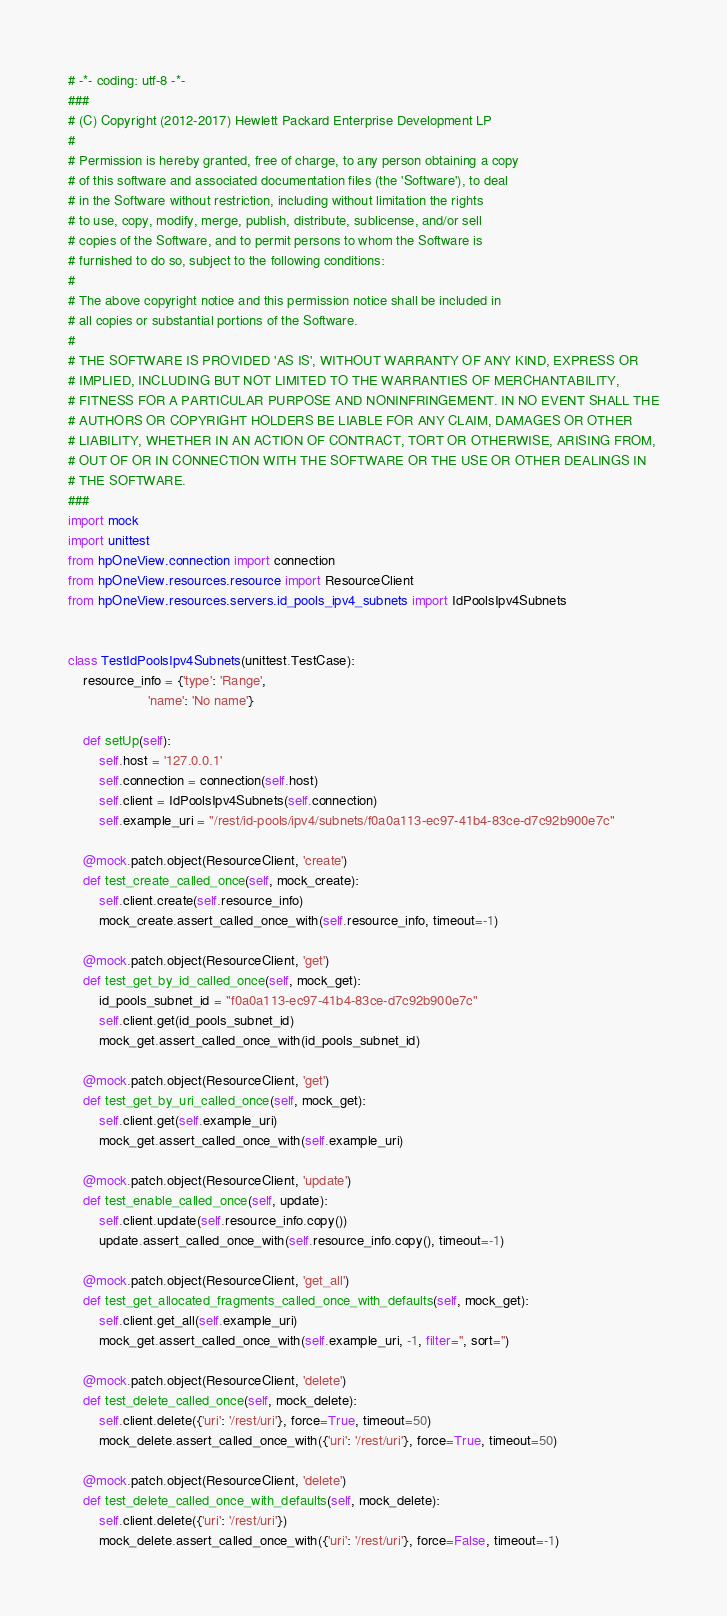Convert code to text. <code><loc_0><loc_0><loc_500><loc_500><_Python_># -*- coding: utf-8 -*-
###
# (C) Copyright (2012-2017) Hewlett Packard Enterprise Development LP
#
# Permission is hereby granted, free of charge, to any person obtaining a copy
# of this software and associated documentation files (the 'Software'), to deal
# in the Software without restriction, including without limitation the rights
# to use, copy, modify, merge, publish, distribute, sublicense, and/or sell
# copies of the Software, and to permit persons to whom the Software is
# furnished to do so, subject to the following conditions:
#
# The above copyright notice and this permission notice shall be included in
# all copies or substantial portions of the Software.
#
# THE SOFTWARE IS PROVIDED 'AS IS', WITHOUT WARRANTY OF ANY KIND, EXPRESS OR
# IMPLIED, INCLUDING BUT NOT LIMITED TO THE WARRANTIES OF MERCHANTABILITY,
# FITNESS FOR A PARTICULAR PURPOSE AND NONINFRINGEMENT. IN NO EVENT SHALL THE
# AUTHORS OR COPYRIGHT HOLDERS BE LIABLE FOR ANY CLAIM, DAMAGES OR OTHER
# LIABILITY, WHETHER IN AN ACTION OF CONTRACT, TORT OR OTHERWISE, ARISING FROM,
# OUT OF OR IN CONNECTION WITH THE SOFTWARE OR THE USE OR OTHER DEALINGS IN
# THE SOFTWARE.
###
import mock
import unittest
from hpOneView.connection import connection
from hpOneView.resources.resource import ResourceClient
from hpOneView.resources.servers.id_pools_ipv4_subnets import IdPoolsIpv4Subnets


class TestIdPoolsIpv4Subnets(unittest.TestCase):
    resource_info = {'type': 'Range',
                     'name': 'No name'}

    def setUp(self):
        self.host = '127.0.0.1'
        self.connection = connection(self.host)
        self.client = IdPoolsIpv4Subnets(self.connection)
        self.example_uri = "/rest/id-pools/ipv4/subnets/f0a0a113-ec97-41b4-83ce-d7c92b900e7c"

    @mock.patch.object(ResourceClient, 'create')
    def test_create_called_once(self, mock_create):
        self.client.create(self.resource_info)
        mock_create.assert_called_once_with(self.resource_info, timeout=-1)

    @mock.patch.object(ResourceClient, 'get')
    def test_get_by_id_called_once(self, mock_get):
        id_pools_subnet_id = "f0a0a113-ec97-41b4-83ce-d7c92b900e7c"
        self.client.get(id_pools_subnet_id)
        mock_get.assert_called_once_with(id_pools_subnet_id)

    @mock.patch.object(ResourceClient, 'get')
    def test_get_by_uri_called_once(self, mock_get):
        self.client.get(self.example_uri)
        mock_get.assert_called_once_with(self.example_uri)

    @mock.patch.object(ResourceClient, 'update')
    def test_enable_called_once(self, update):
        self.client.update(self.resource_info.copy())
        update.assert_called_once_with(self.resource_info.copy(), timeout=-1)

    @mock.patch.object(ResourceClient, 'get_all')
    def test_get_allocated_fragments_called_once_with_defaults(self, mock_get):
        self.client.get_all(self.example_uri)
        mock_get.assert_called_once_with(self.example_uri, -1, filter='', sort='')

    @mock.patch.object(ResourceClient, 'delete')
    def test_delete_called_once(self, mock_delete):
        self.client.delete({'uri': '/rest/uri'}, force=True, timeout=50)
        mock_delete.assert_called_once_with({'uri': '/rest/uri'}, force=True, timeout=50)

    @mock.patch.object(ResourceClient, 'delete')
    def test_delete_called_once_with_defaults(self, mock_delete):
        self.client.delete({'uri': '/rest/uri'})
        mock_delete.assert_called_once_with({'uri': '/rest/uri'}, force=False, timeout=-1)
</code> 